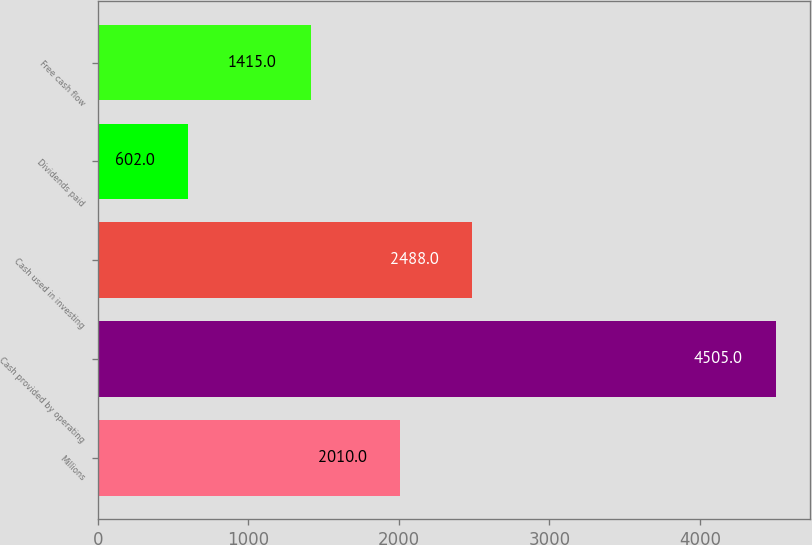<chart> <loc_0><loc_0><loc_500><loc_500><bar_chart><fcel>Millions<fcel>Cash provided by operating<fcel>Cash used in investing<fcel>Dividends paid<fcel>Free cash flow<nl><fcel>2010<fcel>4505<fcel>2488<fcel>602<fcel>1415<nl></chart> 